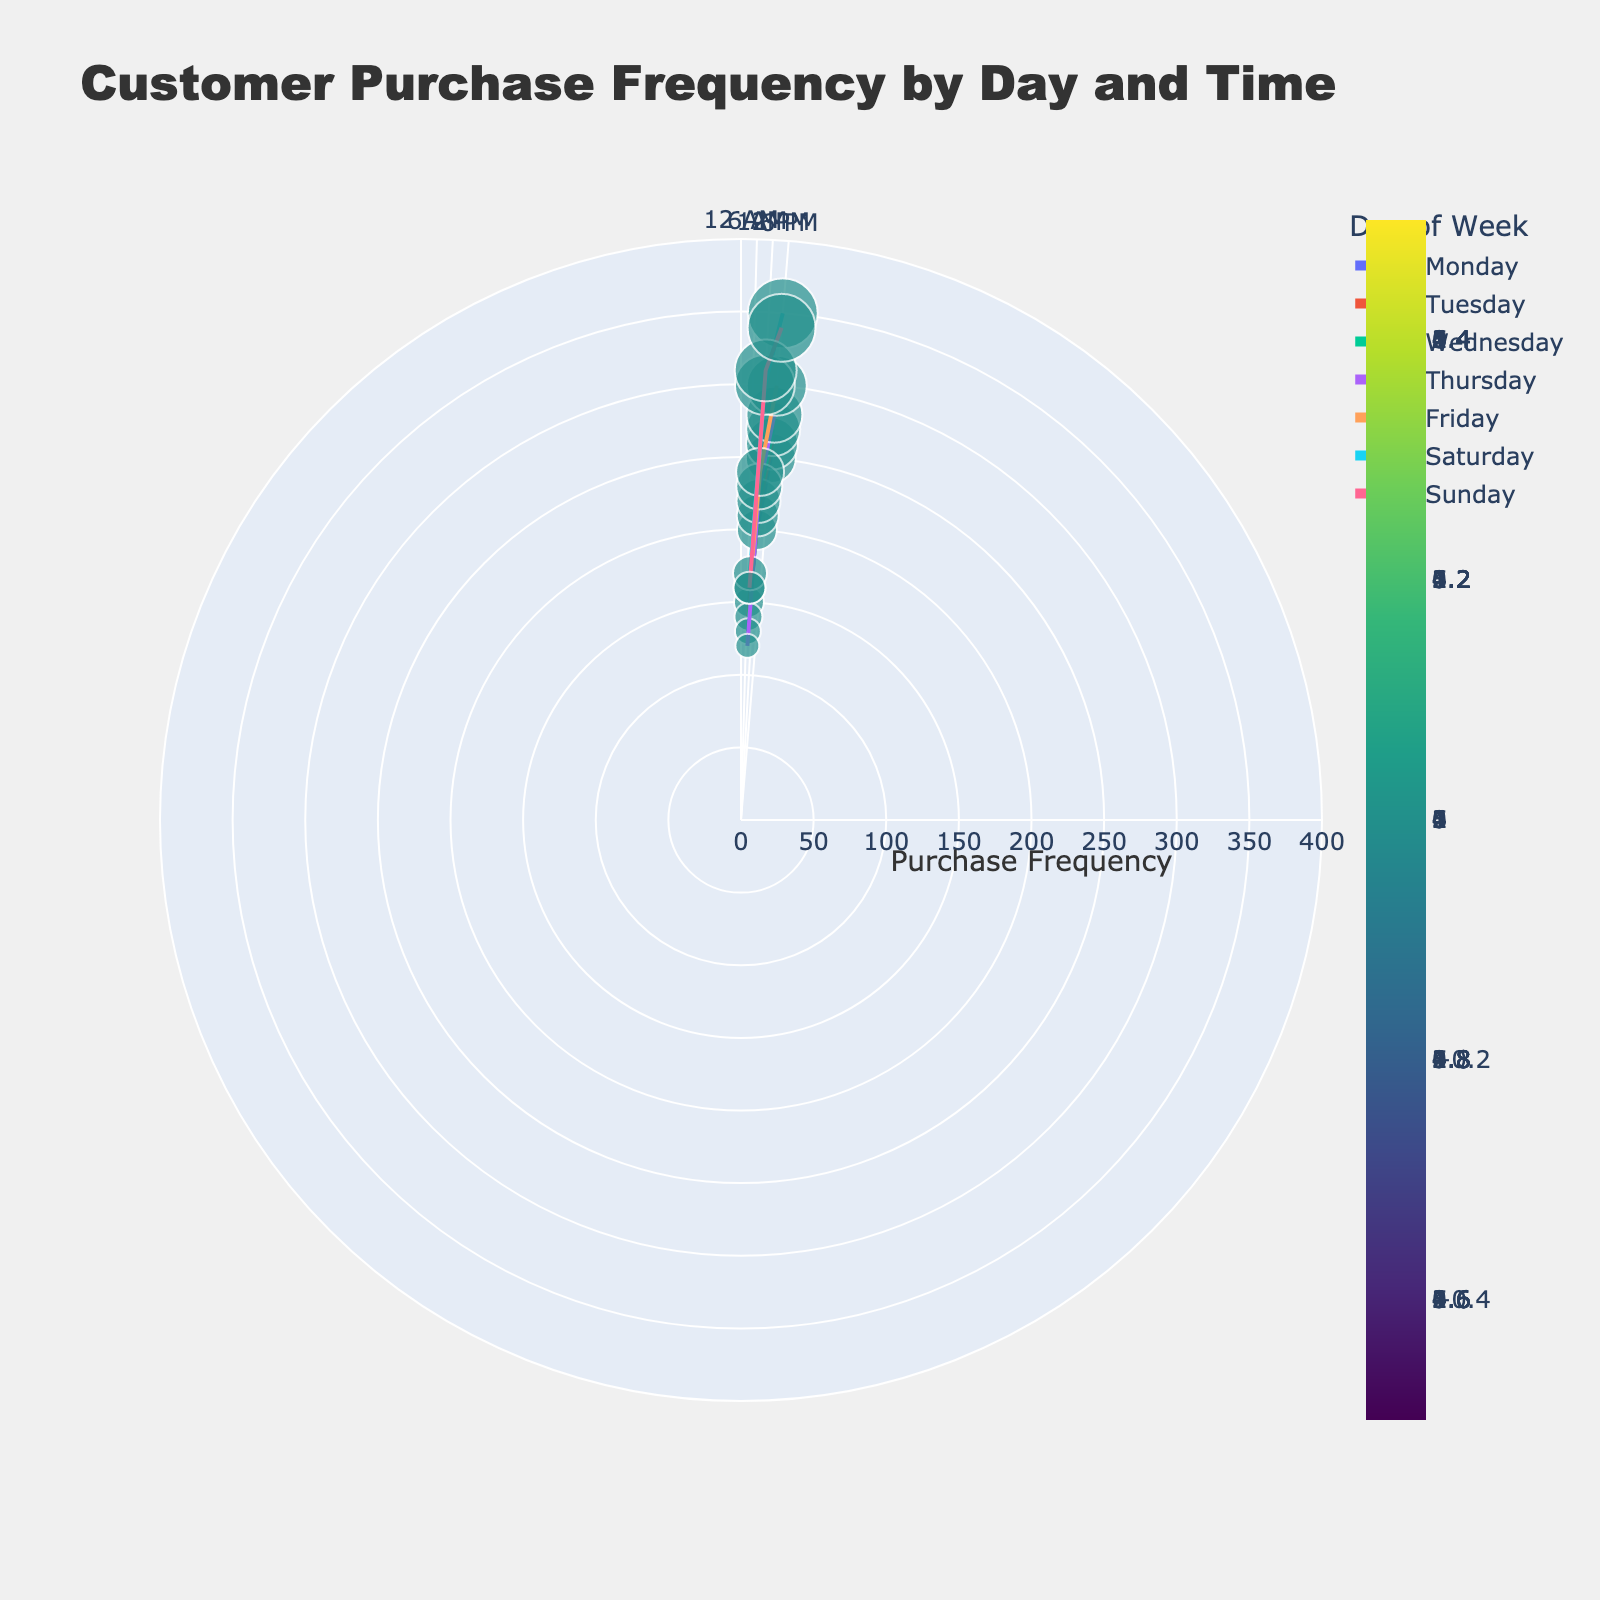What is the highest customer purchase frequency observed on Sunday? Look at the data points corresponding to Sunday and find the highest value. The frequencies are 160, 310, and 340. Hence, the highest is 340.
Answer: 340 Which day has the lowest customer purchase frequency at 8:00 AM? Compare the customer purchase frequencies at 8:00 AM across all the days: Monday (150), Tuesday (140), Wednesday (130), Thursday (120), Friday (160), Saturday (170), and Sunday (160). The lowest is on Thursday with 120.
Answer: Thursday Is the customer purchase frequency at 12:00 PM higher on Saturday or Sunday? Compare the data points for 12:00 PM on Saturday (300) and Sunday (310). Sunday has higher purchase frequency at this time.
Answer: Sunday What is the average customer purchase frequency on Saturdays? Identify the frequencies on Saturday: 170 at 8:00 AM, 300 at 12:00 PM, and 350 at 6:00 PM. Calculate the average by summing them and dividing by 3: (170 + 300 + 350)/3 = 820/3 ≈ 273.33.
Answer: 273.33 Which time of day has the highest customer purchase frequency across the week? For each time slot (8:00 AM, 12:00 PM, and 6:00 PM), find the maximum frequency: 8:00 AM (170 on Saturday), 12:00 PM (310 on Sunday), and 6:00 PM (350 on Saturday). The highest frequency is 350 at 6:00 PM.
Answer: 6:00 PM On which day do customer purchase frequencies show a consistent increase from morning to evening? Examine each day to see if the purchase frequency increases from morning to noon to evening. Only Saturday (170 to 300 to 350) and Sunday (160 to 310 to 340) show consistent increases.
Answer: Saturday and Sunday How does the purchase frequency trend on Fridays compare with that on Mondays? Look at the frequencies for Friday: 160 (8:00 AM), 240 (12:00 PM), and 300 (6:00 PM). For Monday: 150 (8:00 AM), 200 (12:00 PM), and 250 (6:00 PM). Both show increasing trends, but Friday's increase is more significant.
Answer: Friday has a stronger upward trend Are there any days where the purchase frequency at 8:00 AM is higher than at 6:00 PM? Compare the frequencies at 8:00 AM and 6:00 PM for each day. No day has a higher frequency at 8:00 AM compared to 6:00 PM.
Answer: No What is the total customer purchase frequency on weekdays at 12:00 PM? Sum the frequencies for Monday to Friday at 12:00 PM: 200 (Monday) + 210 (Tuesday) + 220 (Wednesday) + 230 (Thursday) + 240 (Friday) = 1100.
Answer: 1100 